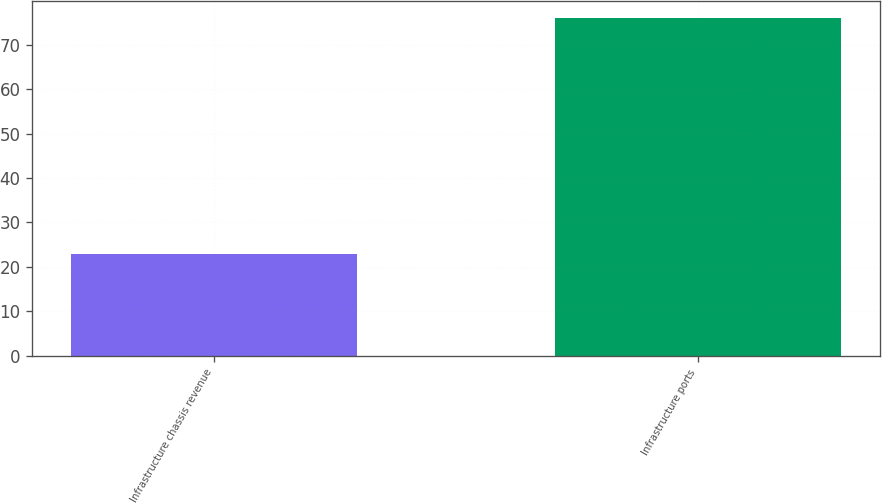<chart> <loc_0><loc_0><loc_500><loc_500><bar_chart><fcel>Infrastructure chassis revenue<fcel>Infrastructure ports<nl><fcel>23<fcel>76<nl></chart> 